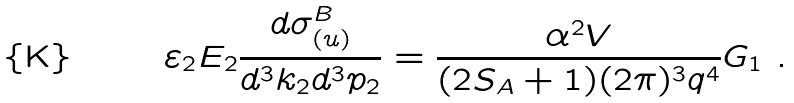Convert formula to latex. <formula><loc_0><loc_0><loc_500><loc_500>\varepsilon _ { 2 } E _ { 2 } \frac { d \sigma ^ { B } _ { ( u ) } } { d ^ { 3 } k _ { 2 } d ^ { 3 } p _ { 2 } } = \frac { \alpha ^ { 2 } V } { ( 2 S _ { A } + 1 ) ( 2 \pi ) ^ { 3 } q ^ { 4 } } G _ { 1 } \ .</formula> 